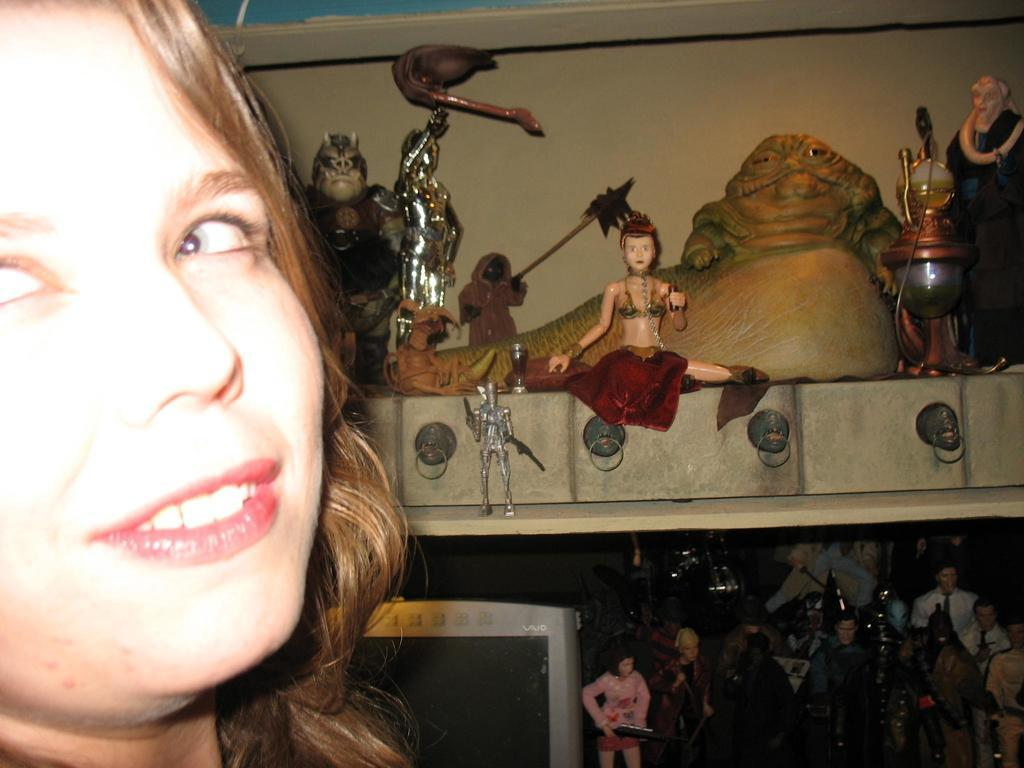What is depicted on the left side of the image? There is a face of a person on the left side of the image. What can be seen on the right side of the image? There are toys and statues on a shelf on the right side of the image. What is the mass of the toys and statues on the shelf in the image? The mass of the toys and statues cannot be determined from the image alone. What is the price of the face of the person on the left side of the image? The image does not provide any information about the price of the face of the person. 